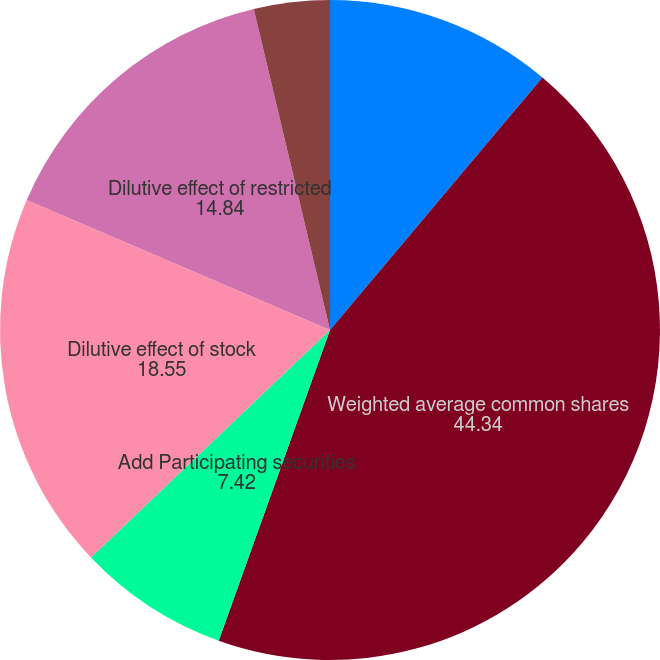Convert chart. <chart><loc_0><loc_0><loc_500><loc_500><pie_chart><fcel>Net income attributable to<fcel>Weighted average common shares<fcel>Add Participating securities<fcel>Dilutive effect of stock<fcel>Dilutive effect of restricted<fcel>Basic earnings per share<fcel>Diluted earnings per share<nl><fcel>11.13%<fcel>44.34%<fcel>7.42%<fcel>18.55%<fcel>14.84%<fcel>3.71%<fcel>0.0%<nl></chart> 